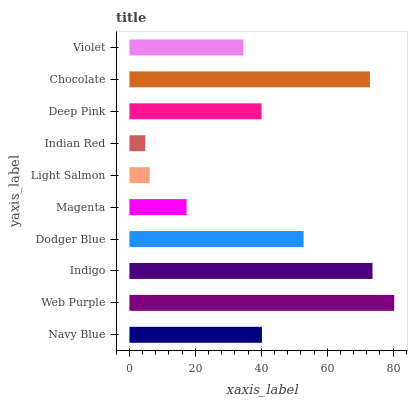Is Indian Red the minimum?
Answer yes or no. Yes. Is Web Purple the maximum?
Answer yes or no. Yes. Is Indigo the minimum?
Answer yes or no. No. Is Indigo the maximum?
Answer yes or no. No. Is Web Purple greater than Indigo?
Answer yes or no. Yes. Is Indigo less than Web Purple?
Answer yes or no. Yes. Is Indigo greater than Web Purple?
Answer yes or no. No. Is Web Purple less than Indigo?
Answer yes or no. No. Is Navy Blue the high median?
Answer yes or no. Yes. Is Deep Pink the low median?
Answer yes or no. Yes. Is Deep Pink the high median?
Answer yes or no. No. Is Indian Red the low median?
Answer yes or no. No. 